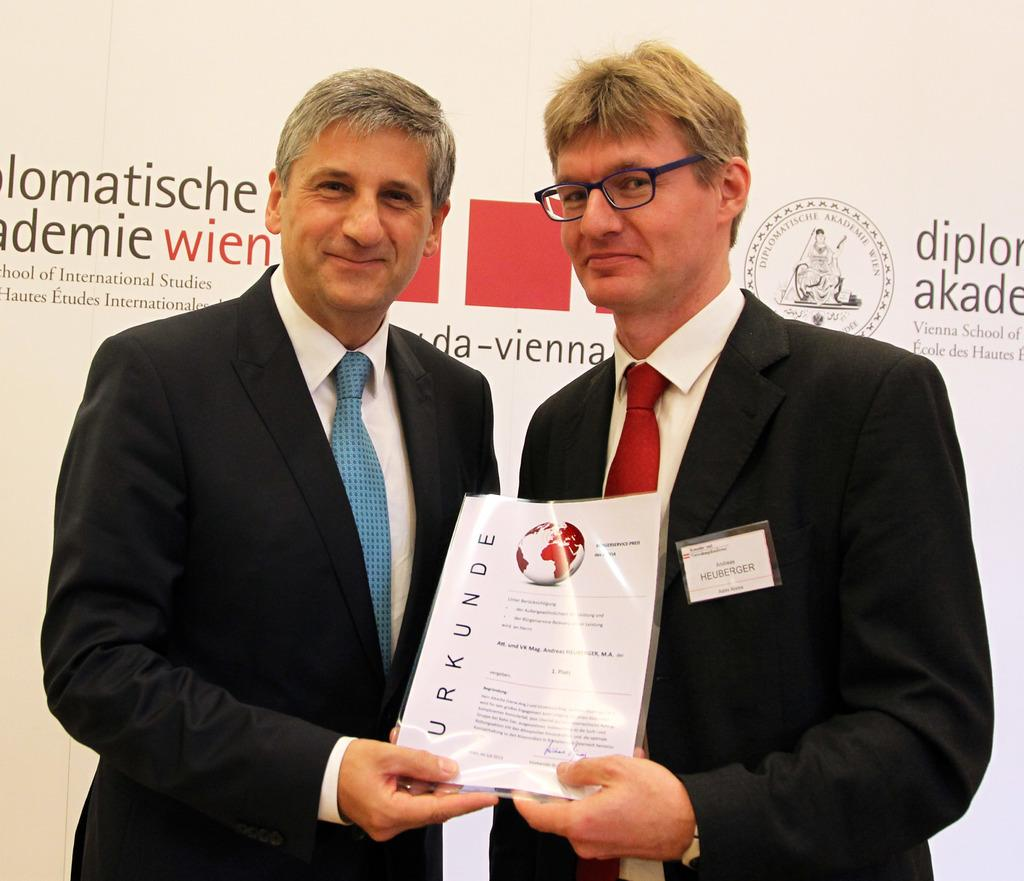How many people are in the image? There are two men in the image. What are the men doing in the image? The men are standing and holding a laminated paper. What can be seen in the background of the image? There is a hoarding in the background of the image. What type of sponge is the man holding in the image? There is no sponge present in the image; the men are holding a laminated paper. What is the name of the metal structure in the image? There is no metal structure present in the image; the background features a hoarding. 